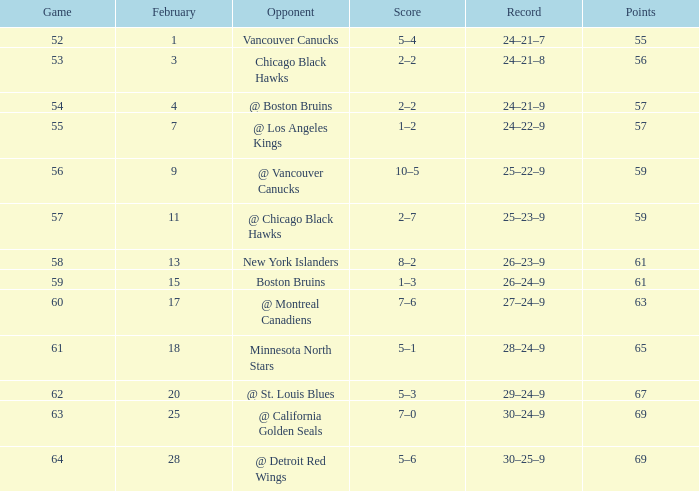Which rival has a game size greater than 61, february shorter than 28, and a point total less than 69? @ St. Louis Blues. 